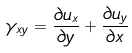Convert formula to latex. <formula><loc_0><loc_0><loc_500><loc_500>\gamma _ { x y } = \frac { \partial u _ { x } } { \partial y } + \frac { \partial u _ { y } } { \partial x }</formula> 